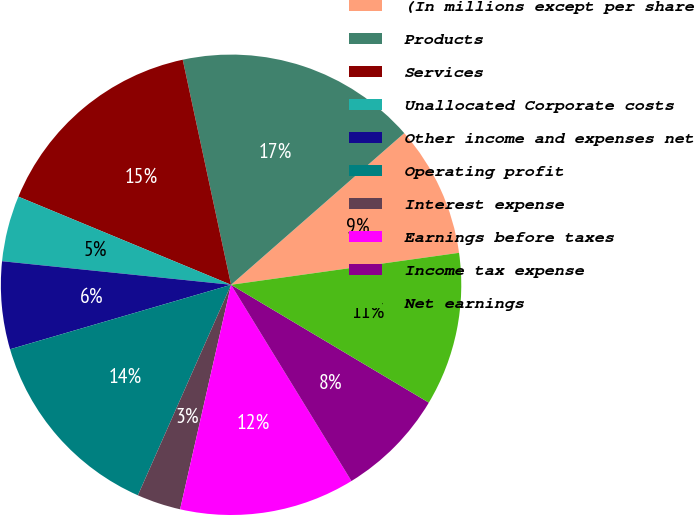Convert chart. <chart><loc_0><loc_0><loc_500><loc_500><pie_chart><fcel>(In millions except per share<fcel>Products<fcel>Services<fcel>Unallocated Corporate costs<fcel>Other income and expenses net<fcel>Operating profit<fcel>Interest expense<fcel>Earnings before taxes<fcel>Income tax expense<fcel>Net earnings<nl><fcel>9.23%<fcel>16.92%<fcel>15.38%<fcel>4.62%<fcel>6.15%<fcel>13.85%<fcel>3.08%<fcel>12.31%<fcel>7.69%<fcel>10.77%<nl></chart> 